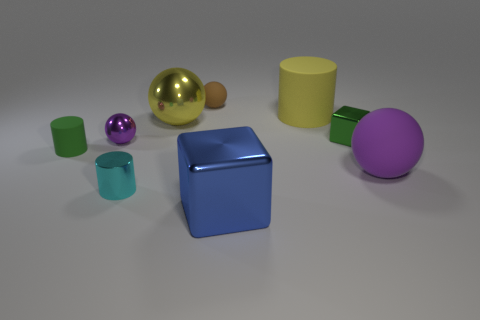Subtract all big yellow matte cylinders. How many cylinders are left? 2 Subtract all green cylinders. How many purple balls are left? 2 Add 1 metal balls. How many objects exist? 10 Subtract 1 cylinders. How many cylinders are left? 2 Subtract all brown spheres. How many spheres are left? 3 Subtract all balls. How many objects are left? 5 Subtract 0 purple cylinders. How many objects are left? 9 Subtract all cyan balls. Subtract all blue cylinders. How many balls are left? 4 Subtract all tiny gray spheres. Subtract all yellow things. How many objects are left? 7 Add 7 yellow things. How many yellow things are left? 9 